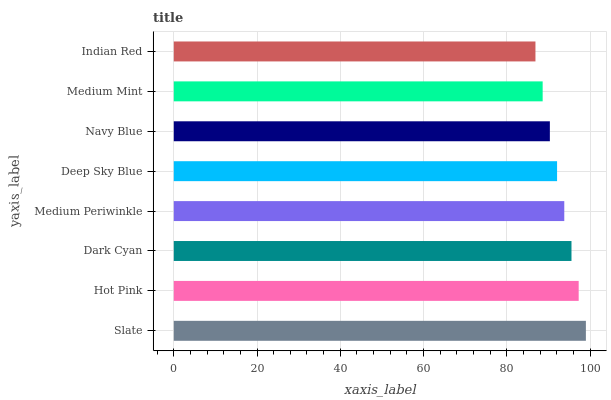Is Indian Red the minimum?
Answer yes or no. Yes. Is Slate the maximum?
Answer yes or no. Yes. Is Hot Pink the minimum?
Answer yes or no. No. Is Hot Pink the maximum?
Answer yes or no. No. Is Slate greater than Hot Pink?
Answer yes or no. Yes. Is Hot Pink less than Slate?
Answer yes or no. Yes. Is Hot Pink greater than Slate?
Answer yes or no. No. Is Slate less than Hot Pink?
Answer yes or no. No. Is Medium Periwinkle the high median?
Answer yes or no. Yes. Is Deep Sky Blue the low median?
Answer yes or no. Yes. Is Indian Red the high median?
Answer yes or no. No. Is Navy Blue the low median?
Answer yes or no. No. 